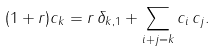Convert formula to latex. <formula><loc_0><loc_0><loc_500><loc_500>( 1 + r ) c _ { k } = r \, \delta _ { k , 1 } + \sum _ { i + j = k } c _ { i } \, c _ { j } .</formula> 